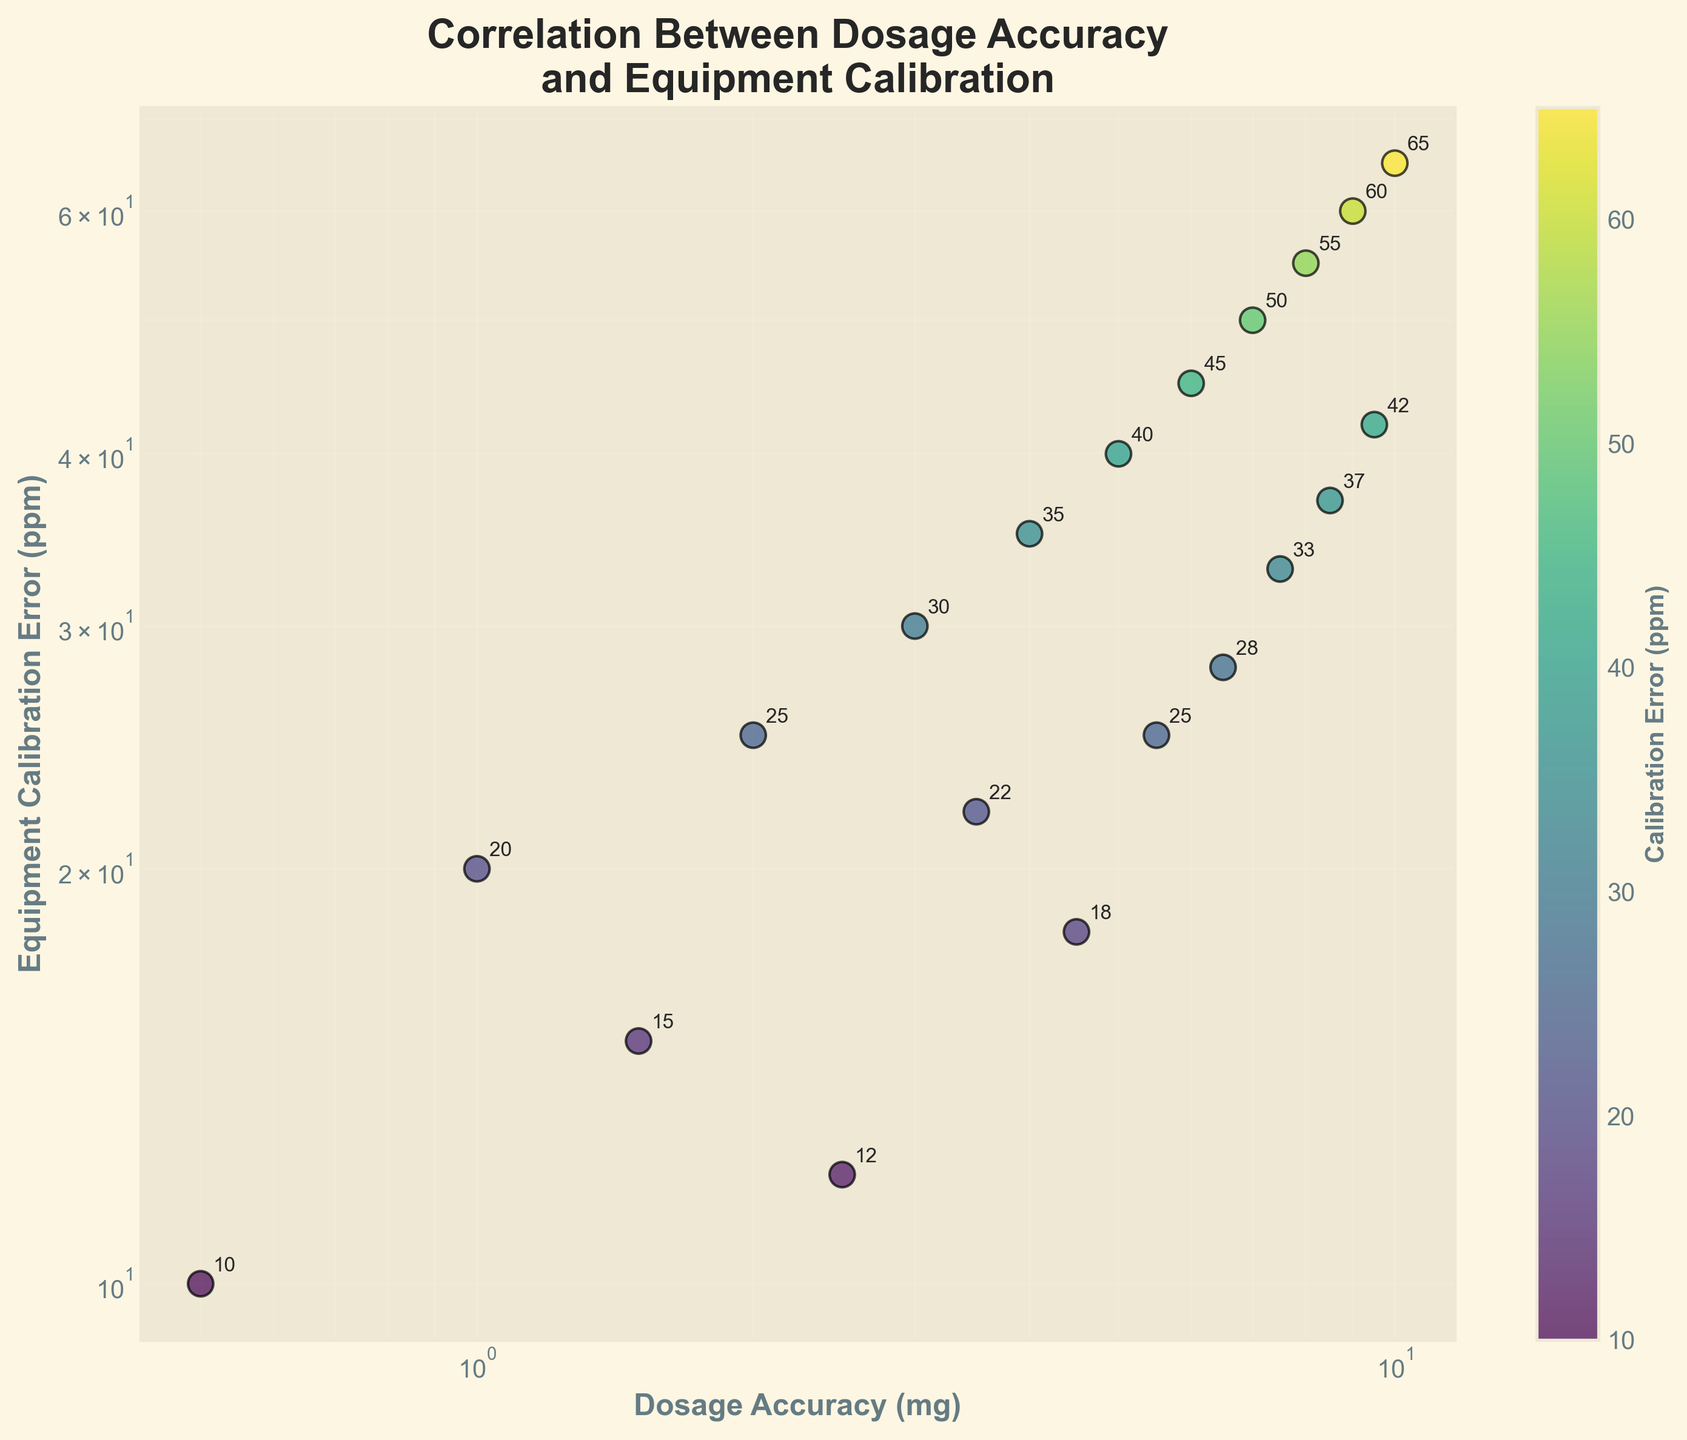What is the title of the scatter plot? The title is usually located at the top of the figure and it provides a quick idea of what the graph is about. The title in this case is "Correlation Between Dosage Accuracy and Equipment Calibration".
Answer: Correlation Between Dosage Accuracy and Equipment Calibration How many data points are there in the scatter plot? The number of data points can be counted directly from the scatter plot where each dot represents a data point. There are 20 data points in total.
Answer: 20 What is the Dosage Accuracy value corresponding to the highest Calibration Error? Look for the data point with the highest Calibration Error on the y-axis and note its corresponding Dosage Accuracy value on the x-axis. The highest Calibration Error (65 ppm) corresponds to a Dosage Accuracy of 10 mg.
Answer: 10 mg Is there a general trend observable between Dosage Accuracy and Calibration Error? Observe the overall pattern of the data points in the scatter plot. The general trend shows that as Dosage Accuracy increases, Calibration Error also tends to increase.
Answer: As Dosage Accuracy increases, Calibration Error tends to increase What is the Calibration Error when the Dosage Accuracy is around 5 mg? Locate the x-axis value of approximately 5 mg and identify the corresponding y-axis value. The Calibration Error around 5 mg Dosage Accuracy is 40 ppm.
Answer: 40 ppm Compare the Calibration Error for Dosage Accuracy at 2.5 mg and 7.5 mg. Which one is higher? Find the points on the scatter plot where Dosage Accuracy is 2.5 mg and 7.5 mg, then compare their corresponding Calibration Error values on the y-axis. The Calibration Errors are 12 ppm for 2.5 mg and 33 ppm for 7.5 mg; 7.5 mg has a higher Calibration Error.
Answer: 7.5 mg What is the median Calibration Error value in the dataset? Sort the Calibration Error values and find the middle one. If the list contains an even number of elements, the median is the average of the two middle numbers. The median of the Calibration Error values {10, 12, 15, 18, 20, 22, 25, 28, 30, 33, 35, 37, 40, 42, 45, 50, 55, 60, 65} is 30 ppm, as it is the 10th element.
Answer: 30 ppm Which data point has the lowest Calibration Error, and what is its Dosage Accuracy? Locate the point on the scatter plot with the lowest y-axis value (Calibration Error), which is 10 ppm, and identify its corresponding x-axis value (Dosage Accuracy), which is 0.5 mg.
Answer: 0.5 mg How does the color of the data points relate to the Calibration Error values? The color of the data points corresponds to the Calibration Error values, as shown by the color bar. Darker colors denote lower Calibration Errors, while lighter colors indicate higher Calibration Errors.
Answer: Darker colors denote lower Calibration Errors Are there any outliers or anomalies in the data? An outlier in this context could be a data point that does not follow the general trend of the data. Upon inspection, there do not appear to be significant outliers in the dataset. All data points roughly follow the upward trend between Dosage Accuracy and Calibration Error.
Answer: No significant outliers 